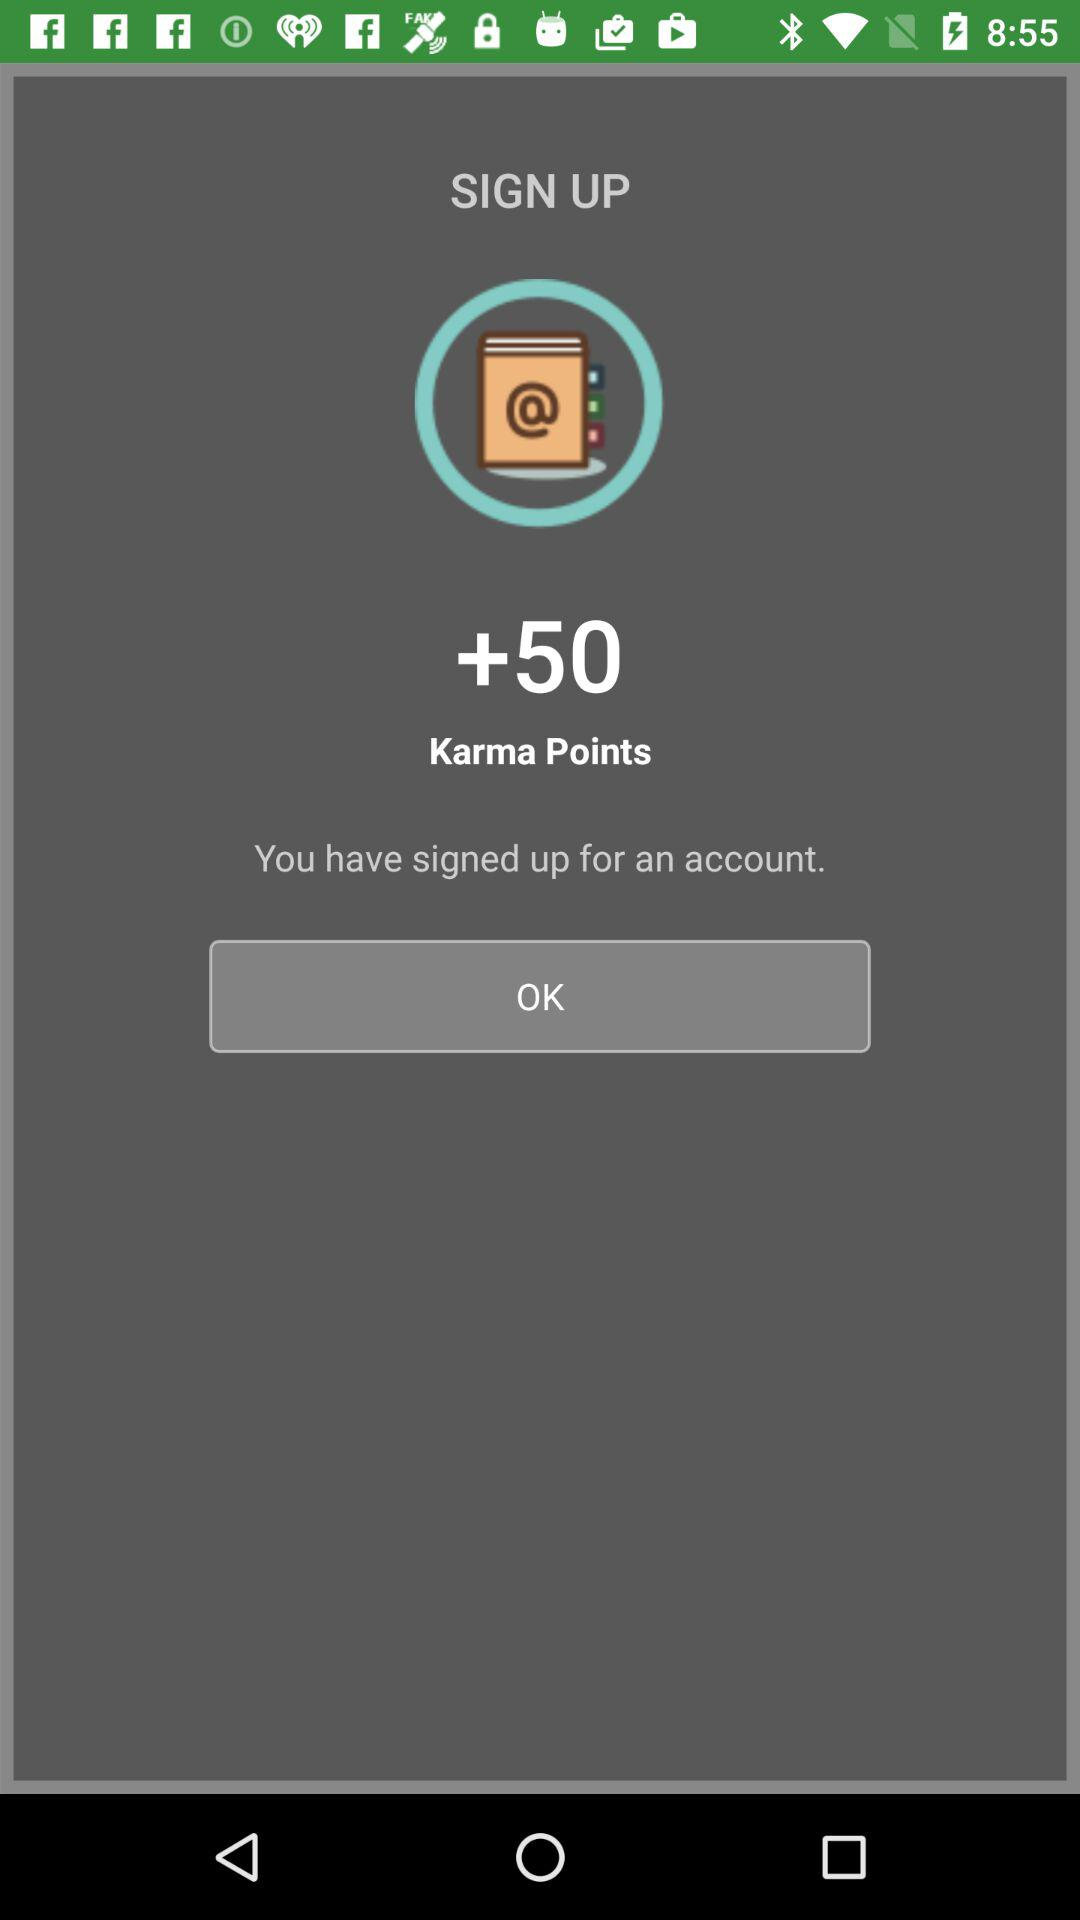How many more karma points does the user have after signing up?
Answer the question using a single word or phrase. 50 